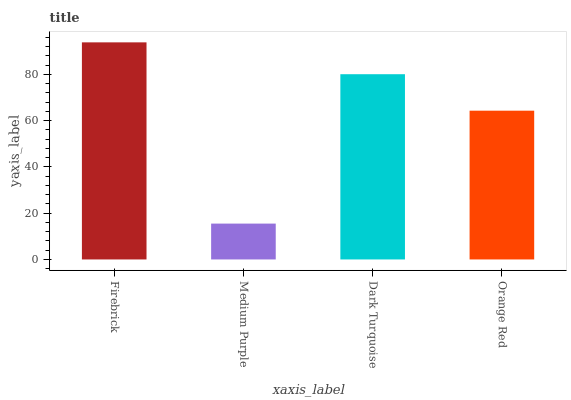Is Medium Purple the minimum?
Answer yes or no. Yes. Is Firebrick the maximum?
Answer yes or no. Yes. Is Dark Turquoise the minimum?
Answer yes or no. No. Is Dark Turquoise the maximum?
Answer yes or no. No. Is Dark Turquoise greater than Medium Purple?
Answer yes or no. Yes. Is Medium Purple less than Dark Turquoise?
Answer yes or no. Yes. Is Medium Purple greater than Dark Turquoise?
Answer yes or no. No. Is Dark Turquoise less than Medium Purple?
Answer yes or no. No. Is Dark Turquoise the high median?
Answer yes or no. Yes. Is Orange Red the low median?
Answer yes or no. Yes. Is Orange Red the high median?
Answer yes or no. No. Is Medium Purple the low median?
Answer yes or no. No. 